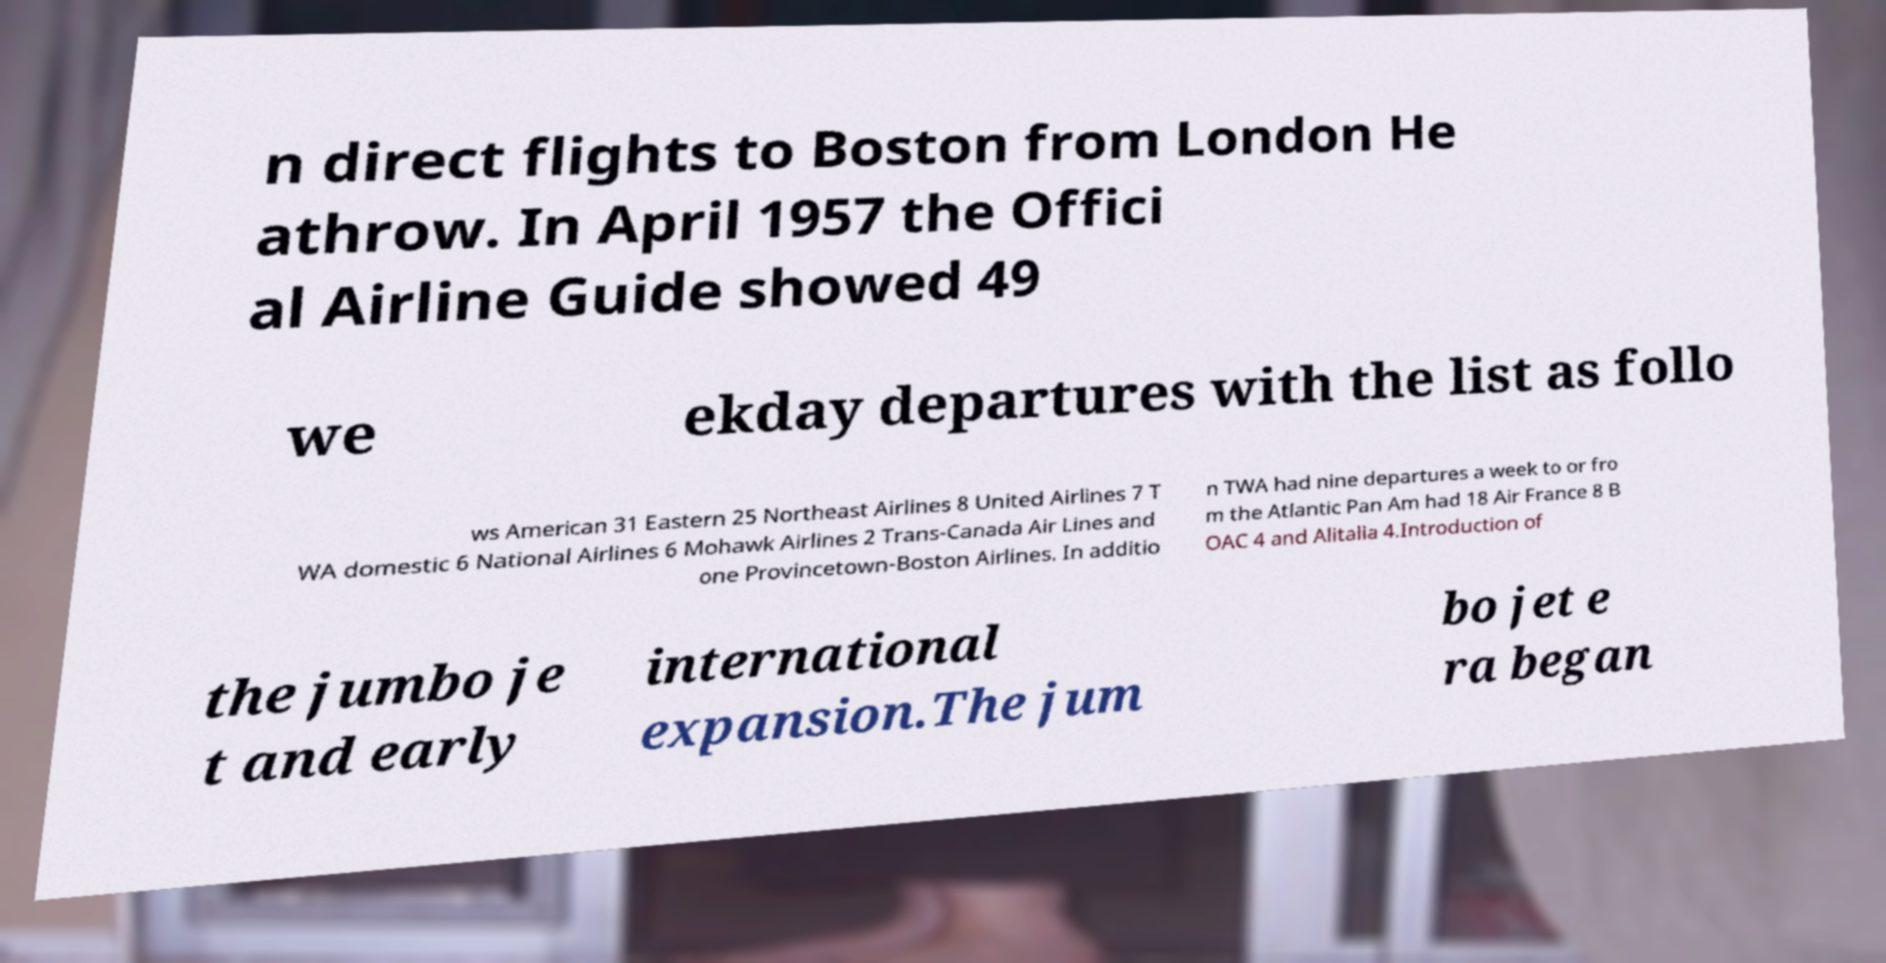Can you read and provide the text displayed in the image?This photo seems to have some interesting text. Can you extract and type it out for me? n direct flights to Boston from London He athrow. In April 1957 the Offici al Airline Guide showed 49 we ekday departures with the list as follo ws American 31 Eastern 25 Northeast Airlines 8 United Airlines 7 T WA domestic 6 National Airlines 6 Mohawk Airlines 2 Trans-Canada Air Lines and one Provincetown-Boston Airlines. In additio n TWA had nine departures a week to or fro m the Atlantic Pan Am had 18 Air France 8 B OAC 4 and Alitalia 4.Introduction of the jumbo je t and early international expansion.The jum bo jet e ra began 